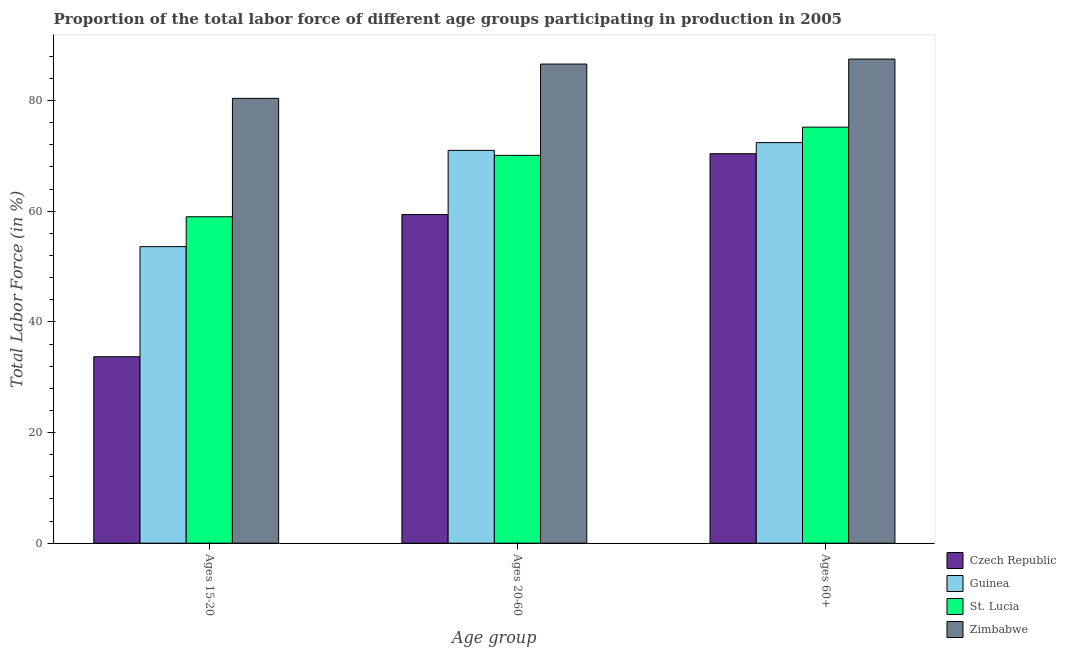How many different coloured bars are there?
Your answer should be compact. 4. Are the number of bars per tick equal to the number of legend labels?
Ensure brevity in your answer.  Yes. Are the number of bars on each tick of the X-axis equal?
Keep it short and to the point. Yes. How many bars are there on the 3rd tick from the left?
Provide a short and direct response. 4. What is the label of the 1st group of bars from the left?
Ensure brevity in your answer.  Ages 15-20. What is the percentage of labor force within the age group 20-60 in Zimbabwe?
Make the answer very short. 86.6. Across all countries, what is the maximum percentage of labor force within the age group 15-20?
Make the answer very short. 80.4. Across all countries, what is the minimum percentage of labor force within the age group 20-60?
Your answer should be very brief. 59.4. In which country was the percentage of labor force within the age group 20-60 maximum?
Ensure brevity in your answer.  Zimbabwe. In which country was the percentage of labor force above age 60 minimum?
Your answer should be compact. Czech Republic. What is the total percentage of labor force within the age group 15-20 in the graph?
Offer a terse response. 226.7. What is the difference between the percentage of labor force within the age group 15-20 in Guinea and that in St. Lucia?
Provide a short and direct response. -5.4. What is the difference between the percentage of labor force within the age group 20-60 in Zimbabwe and the percentage of labor force above age 60 in Guinea?
Offer a terse response. 14.2. What is the average percentage of labor force within the age group 20-60 per country?
Your response must be concise. 71.77. What is the difference between the percentage of labor force within the age group 20-60 and percentage of labor force above age 60 in Czech Republic?
Keep it short and to the point. -11. In how many countries, is the percentage of labor force within the age group 20-60 greater than 24 %?
Offer a very short reply. 4. What is the ratio of the percentage of labor force within the age group 15-20 in St. Lucia to that in Guinea?
Your answer should be compact. 1.1. Is the percentage of labor force above age 60 in Czech Republic less than that in St. Lucia?
Give a very brief answer. Yes. What is the difference between the highest and the second highest percentage of labor force above age 60?
Provide a succinct answer. 12.3. What is the difference between the highest and the lowest percentage of labor force within the age group 15-20?
Offer a very short reply. 46.7. What does the 2nd bar from the left in Ages 15-20 represents?
Your answer should be compact. Guinea. What does the 1st bar from the right in Ages 15-20 represents?
Keep it short and to the point. Zimbabwe. What is the difference between two consecutive major ticks on the Y-axis?
Your answer should be very brief. 20. Where does the legend appear in the graph?
Provide a short and direct response. Bottom right. How many legend labels are there?
Provide a succinct answer. 4. What is the title of the graph?
Keep it short and to the point. Proportion of the total labor force of different age groups participating in production in 2005. Does "West Bank and Gaza" appear as one of the legend labels in the graph?
Offer a terse response. No. What is the label or title of the X-axis?
Provide a succinct answer. Age group. What is the Total Labor Force (in %) in Czech Republic in Ages 15-20?
Provide a succinct answer. 33.7. What is the Total Labor Force (in %) in Guinea in Ages 15-20?
Offer a terse response. 53.6. What is the Total Labor Force (in %) in St. Lucia in Ages 15-20?
Provide a succinct answer. 59. What is the Total Labor Force (in %) in Zimbabwe in Ages 15-20?
Keep it short and to the point. 80.4. What is the Total Labor Force (in %) in Czech Republic in Ages 20-60?
Provide a short and direct response. 59.4. What is the Total Labor Force (in %) in St. Lucia in Ages 20-60?
Your answer should be very brief. 70.1. What is the Total Labor Force (in %) in Zimbabwe in Ages 20-60?
Provide a short and direct response. 86.6. What is the Total Labor Force (in %) in Czech Republic in Ages 60+?
Ensure brevity in your answer.  70.4. What is the Total Labor Force (in %) in Guinea in Ages 60+?
Ensure brevity in your answer.  72.4. What is the Total Labor Force (in %) in St. Lucia in Ages 60+?
Make the answer very short. 75.2. What is the Total Labor Force (in %) in Zimbabwe in Ages 60+?
Make the answer very short. 87.5. Across all Age group, what is the maximum Total Labor Force (in %) of Czech Republic?
Keep it short and to the point. 70.4. Across all Age group, what is the maximum Total Labor Force (in %) of Guinea?
Offer a terse response. 72.4. Across all Age group, what is the maximum Total Labor Force (in %) in St. Lucia?
Your answer should be compact. 75.2. Across all Age group, what is the maximum Total Labor Force (in %) in Zimbabwe?
Your answer should be compact. 87.5. Across all Age group, what is the minimum Total Labor Force (in %) of Czech Republic?
Provide a short and direct response. 33.7. Across all Age group, what is the minimum Total Labor Force (in %) of Guinea?
Give a very brief answer. 53.6. Across all Age group, what is the minimum Total Labor Force (in %) in Zimbabwe?
Make the answer very short. 80.4. What is the total Total Labor Force (in %) in Czech Republic in the graph?
Provide a short and direct response. 163.5. What is the total Total Labor Force (in %) in Guinea in the graph?
Offer a terse response. 197. What is the total Total Labor Force (in %) in St. Lucia in the graph?
Offer a very short reply. 204.3. What is the total Total Labor Force (in %) of Zimbabwe in the graph?
Your answer should be compact. 254.5. What is the difference between the Total Labor Force (in %) in Czech Republic in Ages 15-20 and that in Ages 20-60?
Make the answer very short. -25.7. What is the difference between the Total Labor Force (in %) of Guinea in Ages 15-20 and that in Ages 20-60?
Provide a short and direct response. -17.4. What is the difference between the Total Labor Force (in %) in Zimbabwe in Ages 15-20 and that in Ages 20-60?
Make the answer very short. -6.2. What is the difference between the Total Labor Force (in %) in Czech Republic in Ages 15-20 and that in Ages 60+?
Give a very brief answer. -36.7. What is the difference between the Total Labor Force (in %) of Guinea in Ages 15-20 and that in Ages 60+?
Provide a succinct answer. -18.8. What is the difference between the Total Labor Force (in %) of St. Lucia in Ages 15-20 and that in Ages 60+?
Give a very brief answer. -16.2. What is the difference between the Total Labor Force (in %) in Zimbabwe in Ages 15-20 and that in Ages 60+?
Offer a very short reply. -7.1. What is the difference between the Total Labor Force (in %) in Guinea in Ages 20-60 and that in Ages 60+?
Provide a succinct answer. -1.4. What is the difference between the Total Labor Force (in %) of St. Lucia in Ages 20-60 and that in Ages 60+?
Offer a terse response. -5.1. What is the difference between the Total Labor Force (in %) in Czech Republic in Ages 15-20 and the Total Labor Force (in %) in Guinea in Ages 20-60?
Ensure brevity in your answer.  -37.3. What is the difference between the Total Labor Force (in %) of Czech Republic in Ages 15-20 and the Total Labor Force (in %) of St. Lucia in Ages 20-60?
Ensure brevity in your answer.  -36.4. What is the difference between the Total Labor Force (in %) of Czech Republic in Ages 15-20 and the Total Labor Force (in %) of Zimbabwe in Ages 20-60?
Keep it short and to the point. -52.9. What is the difference between the Total Labor Force (in %) of Guinea in Ages 15-20 and the Total Labor Force (in %) of St. Lucia in Ages 20-60?
Keep it short and to the point. -16.5. What is the difference between the Total Labor Force (in %) in Guinea in Ages 15-20 and the Total Labor Force (in %) in Zimbabwe in Ages 20-60?
Offer a very short reply. -33. What is the difference between the Total Labor Force (in %) in St. Lucia in Ages 15-20 and the Total Labor Force (in %) in Zimbabwe in Ages 20-60?
Ensure brevity in your answer.  -27.6. What is the difference between the Total Labor Force (in %) of Czech Republic in Ages 15-20 and the Total Labor Force (in %) of Guinea in Ages 60+?
Provide a succinct answer. -38.7. What is the difference between the Total Labor Force (in %) in Czech Republic in Ages 15-20 and the Total Labor Force (in %) in St. Lucia in Ages 60+?
Your answer should be very brief. -41.5. What is the difference between the Total Labor Force (in %) of Czech Republic in Ages 15-20 and the Total Labor Force (in %) of Zimbabwe in Ages 60+?
Your response must be concise. -53.8. What is the difference between the Total Labor Force (in %) of Guinea in Ages 15-20 and the Total Labor Force (in %) of St. Lucia in Ages 60+?
Offer a very short reply. -21.6. What is the difference between the Total Labor Force (in %) in Guinea in Ages 15-20 and the Total Labor Force (in %) in Zimbabwe in Ages 60+?
Give a very brief answer. -33.9. What is the difference between the Total Labor Force (in %) of St. Lucia in Ages 15-20 and the Total Labor Force (in %) of Zimbabwe in Ages 60+?
Offer a very short reply. -28.5. What is the difference between the Total Labor Force (in %) in Czech Republic in Ages 20-60 and the Total Labor Force (in %) in Guinea in Ages 60+?
Provide a succinct answer. -13. What is the difference between the Total Labor Force (in %) of Czech Republic in Ages 20-60 and the Total Labor Force (in %) of St. Lucia in Ages 60+?
Provide a short and direct response. -15.8. What is the difference between the Total Labor Force (in %) of Czech Republic in Ages 20-60 and the Total Labor Force (in %) of Zimbabwe in Ages 60+?
Give a very brief answer. -28.1. What is the difference between the Total Labor Force (in %) in Guinea in Ages 20-60 and the Total Labor Force (in %) in St. Lucia in Ages 60+?
Offer a very short reply. -4.2. What is the difference between the Total Labor Force (in %) of Guinea in Ages 20-60 and the Total Labor Force (in %) of Zimbabwe in Ages 60+?
Provide a short and direct response. -16.5. What is the difference between the Total Labor Force (in %) in St. Lucia in Ages 20-60 and the Total Labor Force (in %) in Zimbabwe in Ages 60+?
Offer a very short reply. -17.4. What is the average Total Labor Force (in %) in Czech Republic per Age group?
Keep it short and to the point. 54.5. What is the average Total Labor Force (in %) of Guinea per Age group?
Your answer should be compact. 65.67. What is the average Total Labor Force (in %) of St. Lucia per Age group?
Your answer should be very brief. 68.1. What is the average Total Labor Force (in %) in Zimbabwe per Age group?
Your answer should be compact. 84.83. What is the difference between the Total Labor Force (in %) in Czech Republic and Total Labor Force (in %) in Guinea in Ages 15-20?
Ensure brevity in your answer.  -19.9. What is the difference between the Total Labor Force (in %) of Czech Republic and Total Labor Force (in %) of St. Lucia in Ages 15-20?
Offer a terse response. -25.3. What is the difference between the Total Labor Force (in %) in Czech Republic and Total Labor Force (in %) in Zimbabwe in Ages 15-20?
Your answer should be compact. -46.7. What is the difference between the Total Labor Force (in %) of Guinea and Total Labor Force (in %) of St. Lucia in Ages 15-20?
Offer a terse response. -5.4. What is the difference between the Total Labor Force (in %) in Guinea and Total Labor Force (in %) in Zimbabwe in Ages 15-20?
Provide a succinct answer. -26.8. What is the difference between the Total Labor Force (in %) in St. Lucia and Total Labor Force (in %) in Zimbabwe in Ages 15-20?
Offer a very short reply. -21.4. What is the difference between the Total Labor Force (in %) in Czech Republic and Total Labor Force (in %) in Guinea in Ages 20-60?
Provide a succinct answer. -11.6. What is the difference between the Total Labor Force (in %) in Czech Republic and Total Labor Force (in %) in Zimbabwe in Ages 20-60?
Provide a succinct answer. -27.2. What is the difference between the Total Labor Force (in %) in Guinea and Total Labor Force (in %) in St. Lucia in Ages 20-60?
Your answer should be very brief. 0.9. What is the difference between the Total Labor Force (in %) of Guinea and Total Labor Force (in %) of Zimbabwe in Ages 20-60?
Provide a short and direct response. -15.6. What is the difference between the Total Labor Force (in %) of St. Lucia and Total Labor Force (in %) of Zimbabwe in Ages 20-60?
Your answer should be compact. -16.5. What is the difference between the Total Labor Force (in %) in Czech Republic and Total Labor Force (in %) in Guinea in Ages 60+?
Keep it short and to the point. -2. What is the difference between the Total Labor Force (in %) of Czech Republic and Total Labor Force (in %) of St. Lucia in Ages 60+?
Offer a very short reply. -4.8. What is the difference between the Total Labor Force (in %) in Czech Republic and Total Labor Force (in %) in Zimbabwe in Ages 60+?
Offer a terse response. -17.1. What is the difference between the Total Labor Force (in %) in Guinea and Total Labor Force (in %) in Zimbabwe in Ages 60+?
Provide a short and direct response. -15.1. What is the difference between the Total Labor Force (in %) of St. Lucia and Total Labor Force (in %) of Zimbabwe in Ages 60+?
Provide a succinct answer. -12.3. What is the ratio of the Total Labor Force (in %) in Czech Republic in Ages 15-20 to that in Ages 20-60?
Your response must be concise. 0.57. What is the ratio of the Total Labor Force (in %) of Guinea in Ages 15-20 to that in Ages 20-60?
Give a very brief answer. 0.75. What is the ratio of the Total Labor Force (in %) of St. Lucia in Ages 15-20 to that in Ages 20-60?
Provide a succinct answer. 0.84. What is the ratio of the Total Labor Force (in %) of Zimbabwe in Ages 15-20 to that in Ages 20-60?
Your answer should be compact. 0.93. What is the ratio of the Total Labor Force (in %) of Czech Republic in Ages 15-20 to that in Ages 60+?
Offer a very short reply. 0.48. What is the ratio of the Total Labor Force (in %) in Guinea in Ages 15-20 to that in Ages 60+?
Make the answer very short. 0.74. What is the ratio of the Total Labor Force (in %) of St. Lucia in Ages 15-20 to that in Ages 60+?
Give a very brief answer. 0.78. What is the ratio of the Total Labor Force (in %) in Zimbabwe in Ages 15-20 to that in Ages 60+?
Provide a succinct answer. 0.92. What is the ratio of the Total Labor Force (in %) in Czech Republic in Ages 20-60 to that in Ages 60+?
Make the answer very short. 0.84. What is the ratio of the Total Labor Force (in %) in Guinea in Ages 20-60 to that in Ages 60+?
Your answer should be very brief. 0.98. What is the ratio of the Total Labor Force (in %) of St. Lucia in Ages 20-60 to that in Ages 60+?
Your answer should be very brief. 0.93. What is the difference between the highest and the second highest Total Labor Force (in %) in Czech Republic?
Ensure brevity in your answer.  11. What is the difference between the highest and the second highest Total Labor Force (in %) of Zimbabwe?
Keep it short and to the point. 0.9. What is the difference between the highest and the lowest Total Labor Force (in %) of Czech Republic?
Your answer should be very brief. 36.7. What is the difference between the highest and the lowest Total Labor Force (in %) in Guinea?
Make the answer very short. 18.8. 